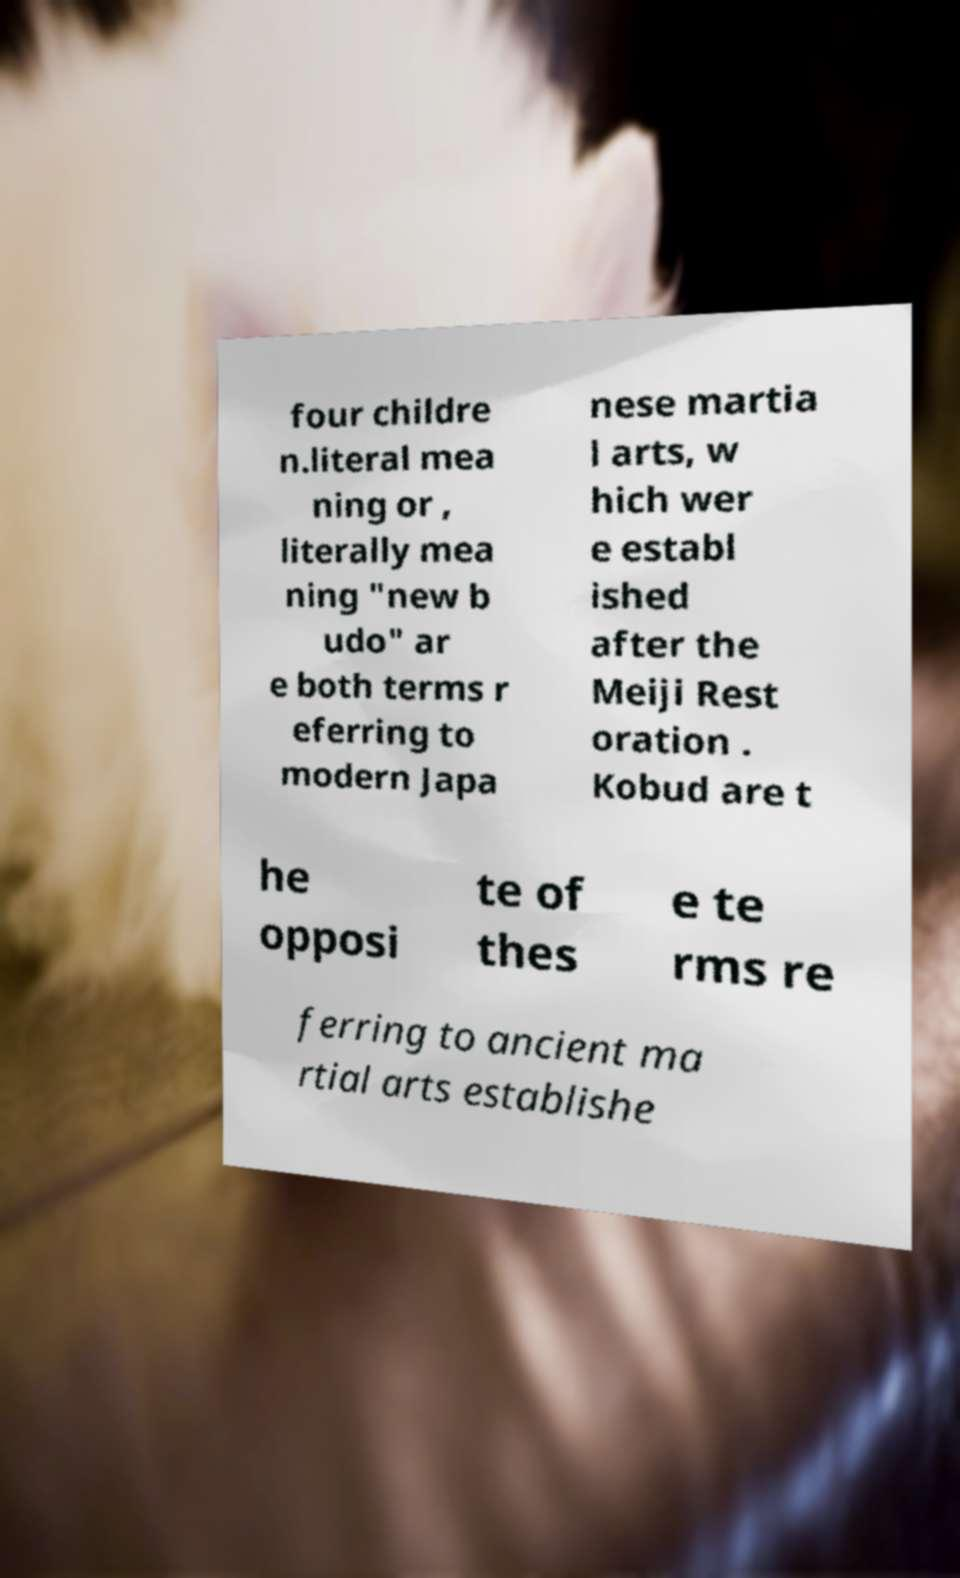What messages or text are displayed in this image? I need them in a readable, typed format. four childre n.literal mea ning or , literally mea ning "new b udo" ar e both terms r eferring to modern Japa nese martia l arts, w hich wer e establ ished after the Meiji Rest oration . Kobud are t he opposi te of thes e te rms re ferring to ancient ma rtial arts establishe 